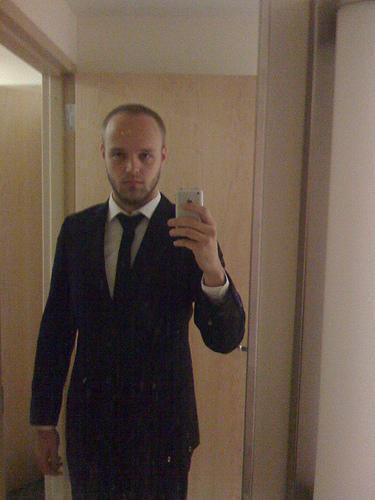How many people are in the picture?
Give a very brief answer. 1. 